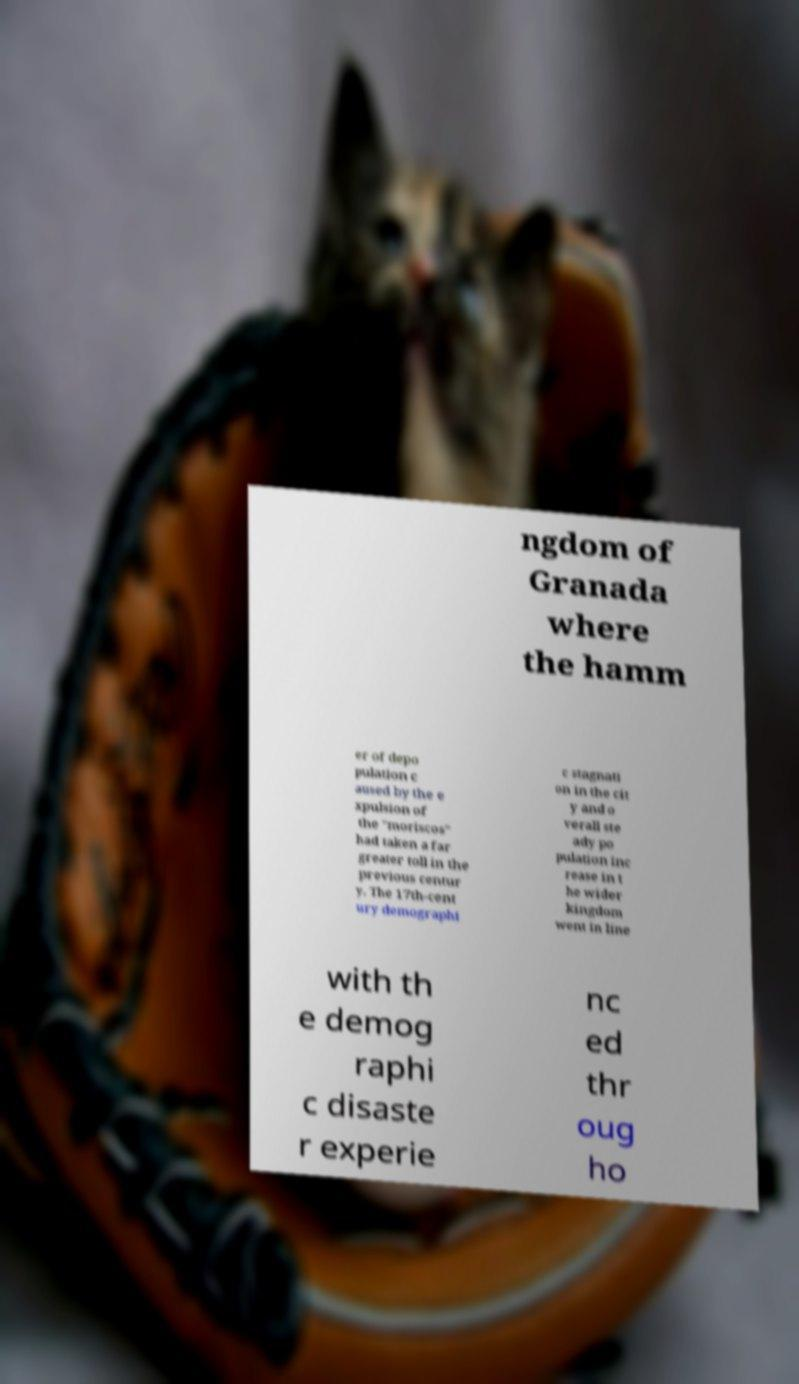Can you read and provide the text displayed in the image?This photo seems to have some interesting text. Can you extract and type it out for me? ngdom of Granada where the hamm er of depo pulation c aused by the e xpulsion of the "moriscos" had taken a far greater toll in the previous centur y. The 17th-cent ury demographi c stagnati on in the cit y and o verall ste ady po pulation inc rease in t he wider kingdom went in line with th e demog raphi c disaste r experie nc ed thr oug ho 